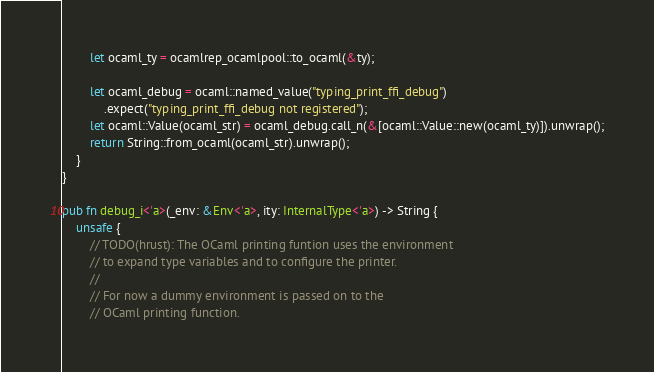Convert code to text. <code><loc_0><loc_0><loc_500><loc_500><_Rust_>        let ocaml_ty = ocamlrep_ocamlpool::to_ocaml(&ty);

        let ocaml_debug = ocaml::named_value("typing_print_ffi_debug")
            .expect("typing_print_ffi_debug not registered");
        let ocaml::Value(ocaml_str) = ocaml_debug.call_n(&[ocaml::Value::new(ocaml_ty)]).unwrap();
        return String::from_ocaml(ocaml_str).unwrap();
    }
}

pub fn debug_i<'a>(_env: &Env<'a>, ity: InternalType<'a>) -> String {
    unsafe {
        // TODO(hrust): The OCaml printing funtion uses the environment
        // to expand type variables and to configure the printer.
        //
        // For now a dummy environment is passed on to the
        // OCaml printing function.</code> 